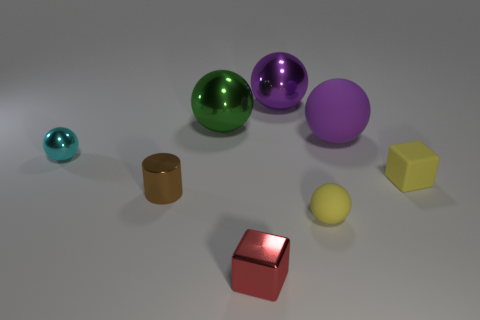Subtract all blue blocks. How many purple balls are left? 2 Subtract all green balls. How many balls are left? 4 Subtract all purple matte spheres. How many spheres are left? 4 Add 1 small brown things. How many objects exist? 9 Subtract all red balls. Subtract all blue cylinders. How many balls are left? 5 Subtract all spheres. How many objects are left? 3 Add 5 red cubes. How many red cubes exist? 6 Subtract 0 cyan cubes. How many objects are left? 8 Subtract all large yellow metal cylinders. Subtract all small metal cubes. How many objects are left? 7 Add 5 tiny cyan metallic spheres. How many tiny cyan metallic spheres are left? 6 